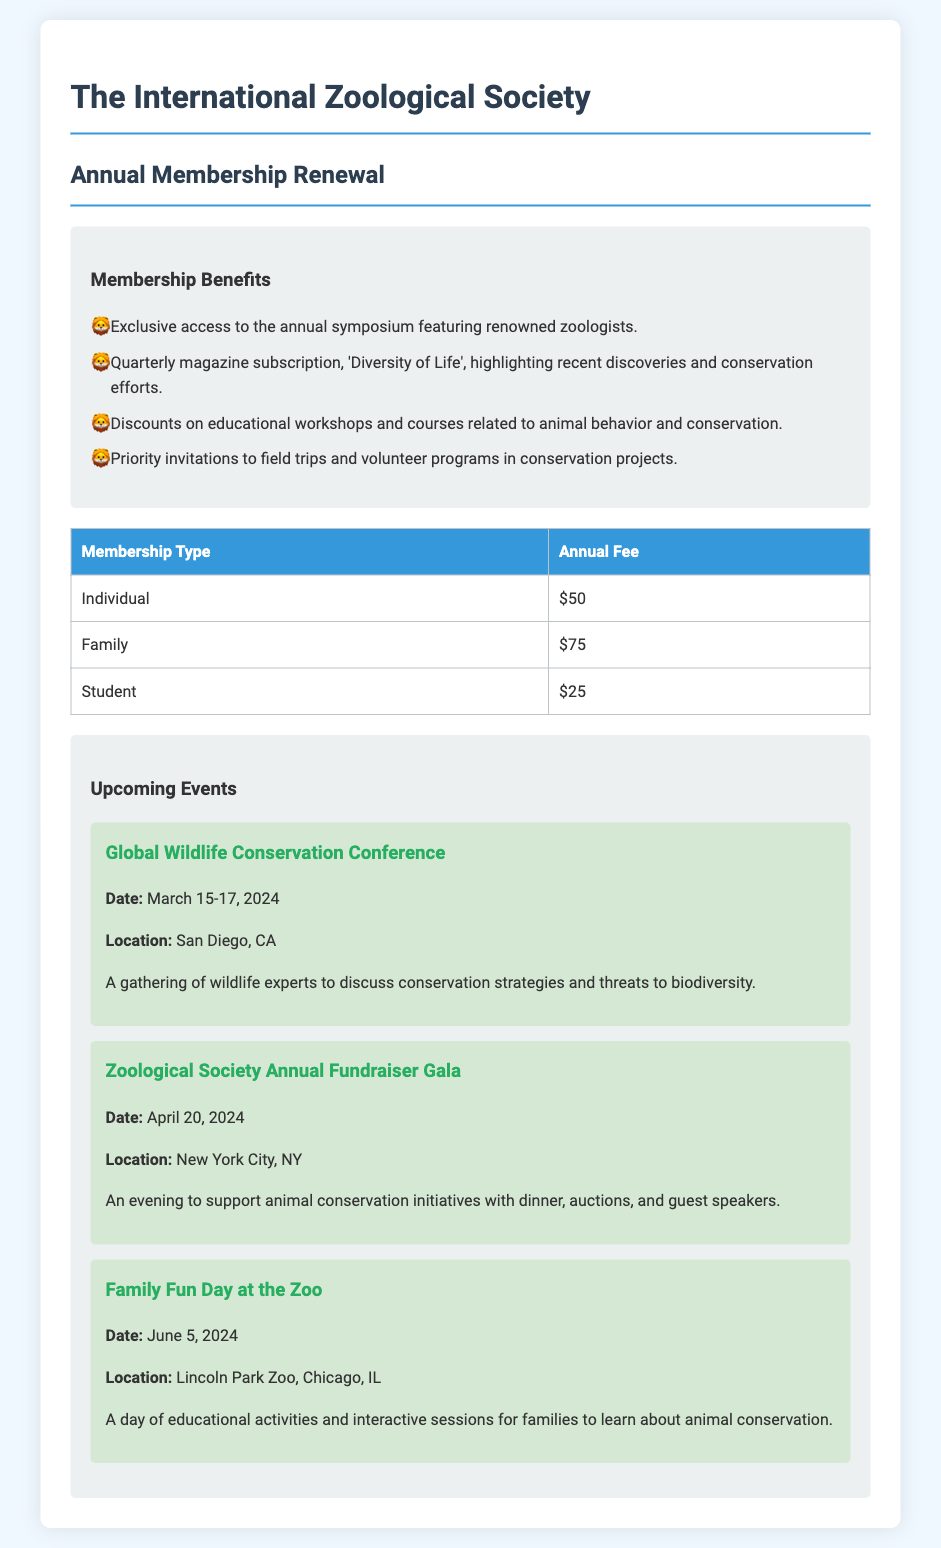What is the individual membership fee? The individual membership fee is stated in the table under "Annual Fee" for "Individual".
Answer: $50 When is the Global Wildlife Conservation Conference? The date of the Global Wildlife Conservation Conference is provided under the event section.
Answer: March 15-17, 2024 What is one benefit of membership? Membership benefits are listed, and one benefit is "Exclusive access to the annual symposium featuring renowned zoologists."
Answer: Exclusive access to the annual symposium How much is the family membership fee? The family membership fee can be found in the fee table.
Answer: $75 Where will the Zoological Society Annual Fundraiser Gala be held? The location for the gala is provided in the event details.
Answer: New York City, NY What type of event is scheduled for June 5, 2024? The type of event is found under the upcoming events with the title provided in the details.
Answer: Family Fun Day at the Zoo What is the primary focus of the upcoming Global Wildlife Conservation Conference? The focus of the conference is summarized in the description of the event.
Answer: Conservation strategies and threats to biodiversity How often is the magazine 'Diversity of Life' published? The frequency of publication is mentioned in the benefits section of the document.
Answer: Quarterly 